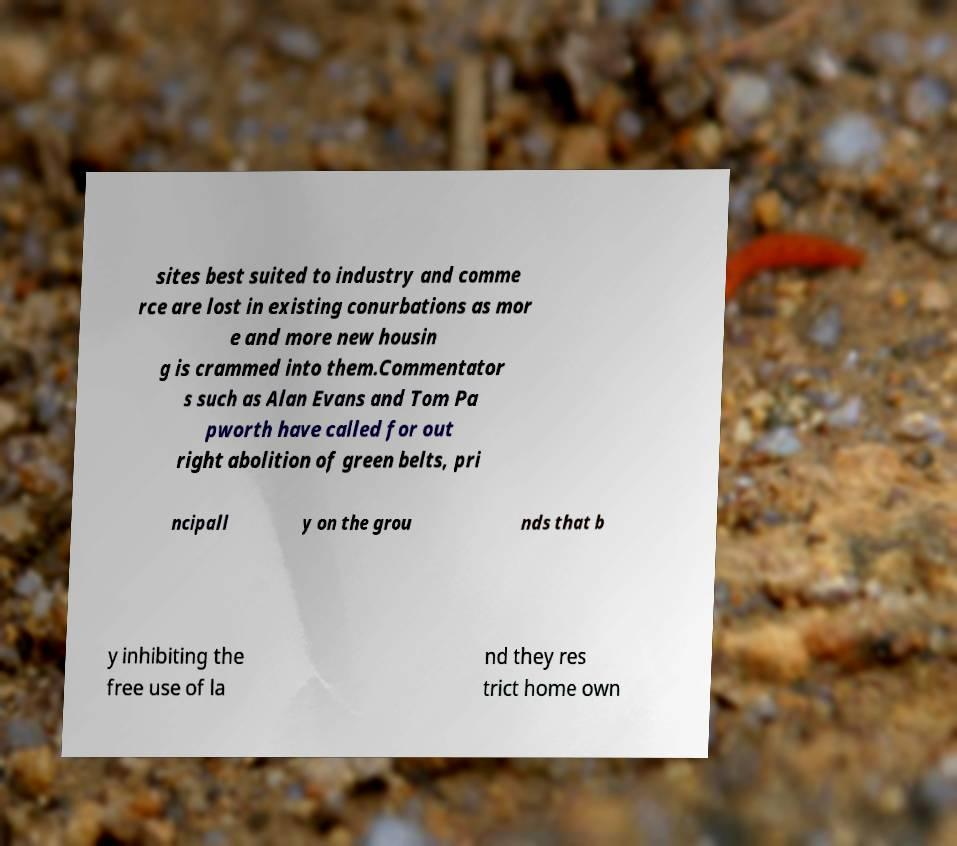Could you assist in decoding the text presented in this image and type it out clearly? sites best suited to industry and comme rce are lost in existing conurbations as mor e and more new housin g is crammed into them.Commentator s such as Alan Evans and Tom Pa pworth have called for out right abolition of green belts, pri ncipall y on the grou nds that b y inhibiting the free use of la nd they res trict home own 